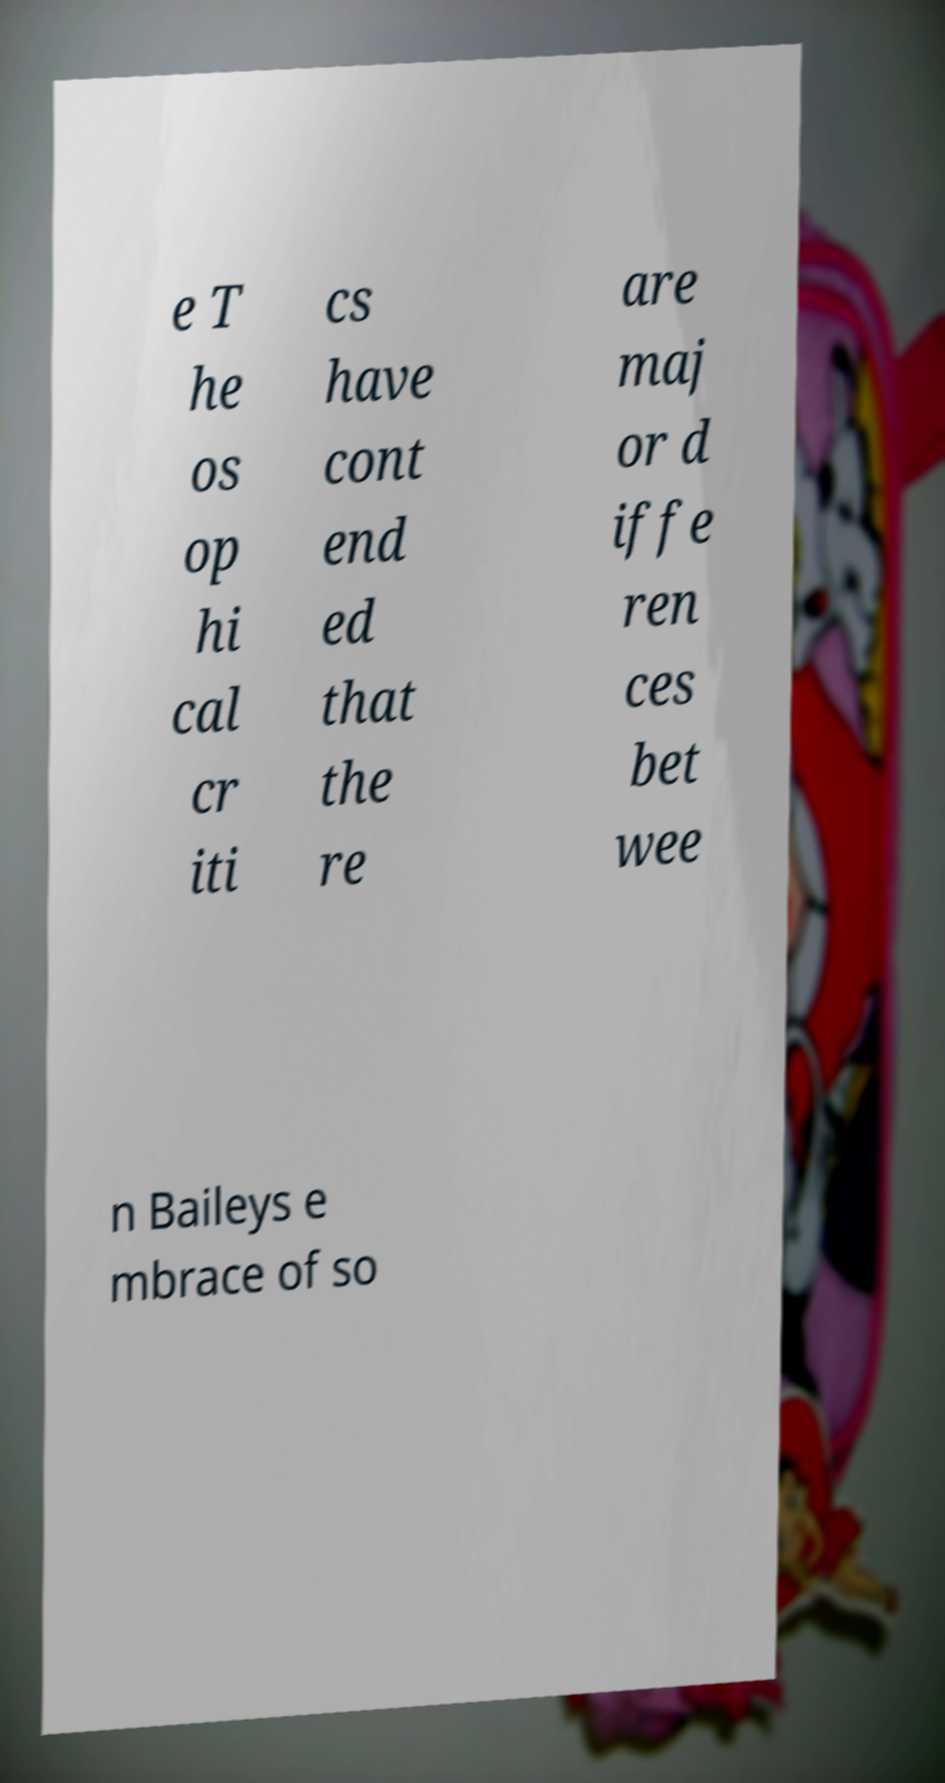Could you extract and type out the text from this image? e T he os op hi cal cr iti cs have cont end ed that the re are maj or d iffe ren ces bet wee n Baileys e mbrace of so 